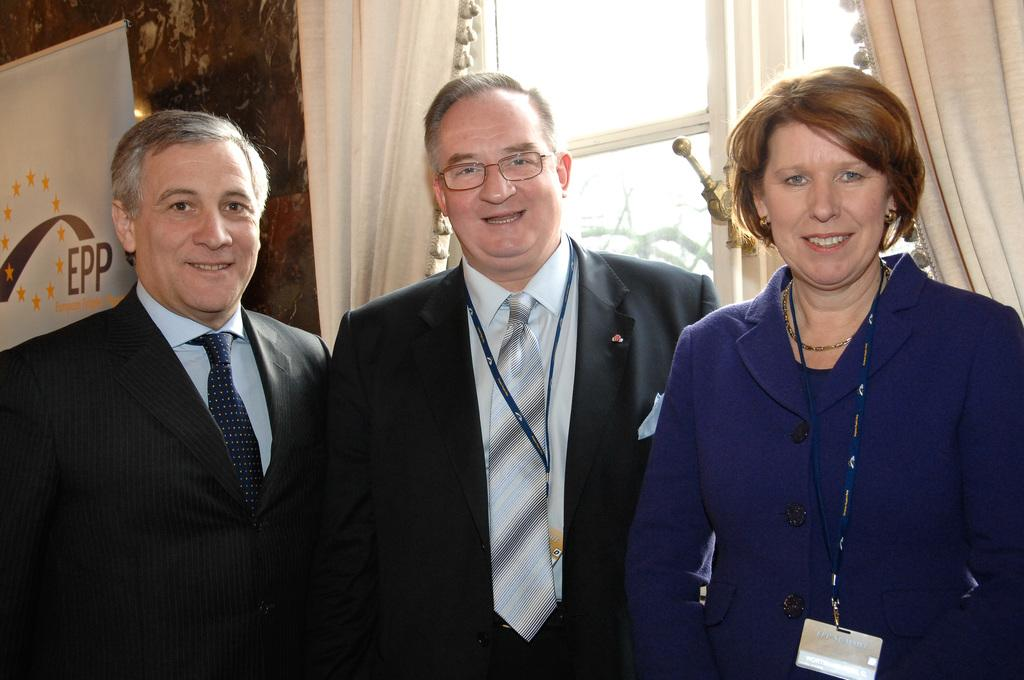How many people are in the image? There are three persons standing in the image. What is the facial expression of the people in the image? The persons are smiling. What can be seen in the background of the image? There is a board, a wall, curtains, and a window in the background of the image. What type of glue is being used to hold the peace plot together in the image? There is no reference to peace, plot, or glue in the image; it features three persons standing and smiling with a background containing a board, wall, curtains, and a window. 